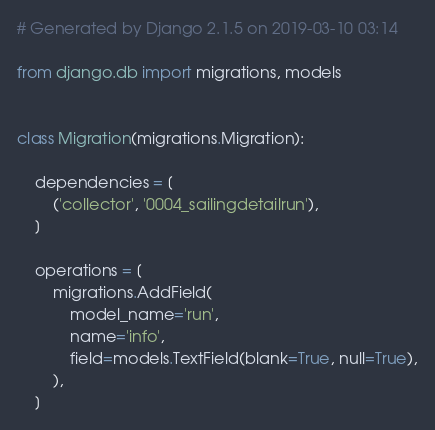<code> <loc_0><loc_0><loc_500><loc_500><_Python_># Generated by Django 2.1.5 on 2019-03-10 03:14

from django.db import migrations, models


class Migration(migrations.Migration):

    dependencies = [
        ('collector', '0004_sailingdetailrun'),
    ]

    operations = [
        migrations.AddField(
            model_name='run',
            name='info',
            field=models.TextField(blank=True, null=True),
        ),
    ]
</code> 